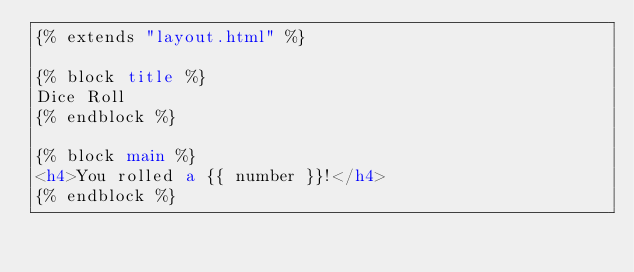Convert code to text. <code><loc_0><loc_0><loc_500><loc_500><_HTML_>{% extends "layout.html" %}

{% block title %}
Dice Roll
{% endblock %}

{% block main %}
<h4>You rolled a {{ number }}!</h4>
{% endblock %}</code> 